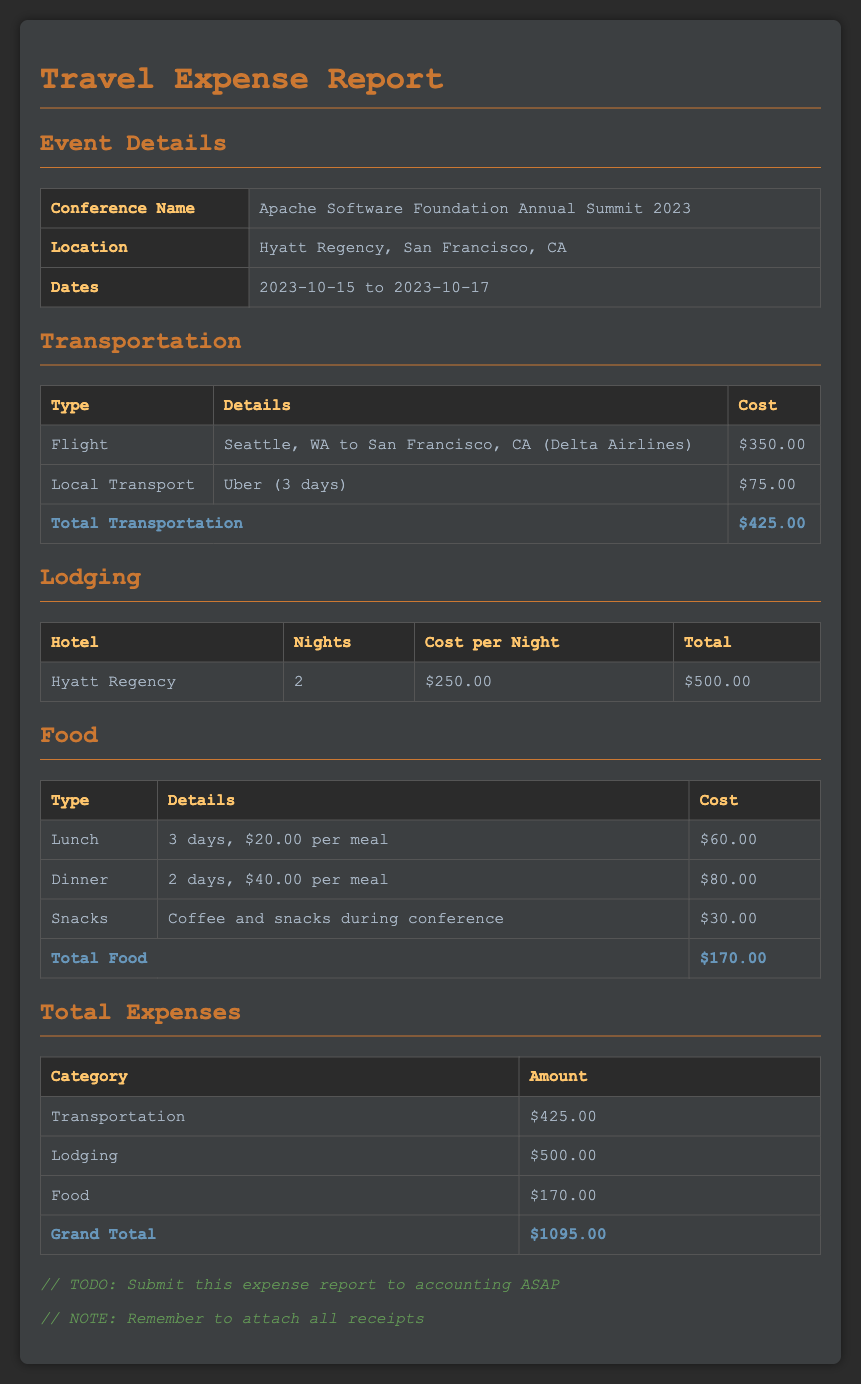What is the conference name? The document states the conference name as the Apache Software Foundation Annual Summit 2023.
Answer: Apache Software Foundation Annual Summit 2023 Where was the event held? The document specifies the location as Hyatt Regency, San Francisco, CA.
Answer: Hyatt Regency, San Francisco, CA What was the total lodging cost? The total lodging cost is provided in the lodging section of the document, which adds up to $500.00.
Answer: $500.00 How many nights did the stay cover? The lodging table indicates the stay covered 2 nights at the hotel.
Answer: 2 What is the total cost for food? The total food cost is listed in the food section, which sums up to $170.00.
Answer: $170.00 What type of transportation was used for local travel? The transportation section mentions using Uber for local transport.
Answer: Uber What was the cost of the flight? The flight cost details indicate the cost was $350.00 for the flight from Seattle to San Francisco.
Answer: $350.00 What is the total amount of all expenses? The total expenses are summarized as the grand total in the document, which amounts to $1095.00.
Answer: $1095.00 What are the dates of the conference? The conference dates are specified in the event details section as 2023-10-15 to 2023-10-17.
Answer: 2023-10-15 to 2023-10-17 